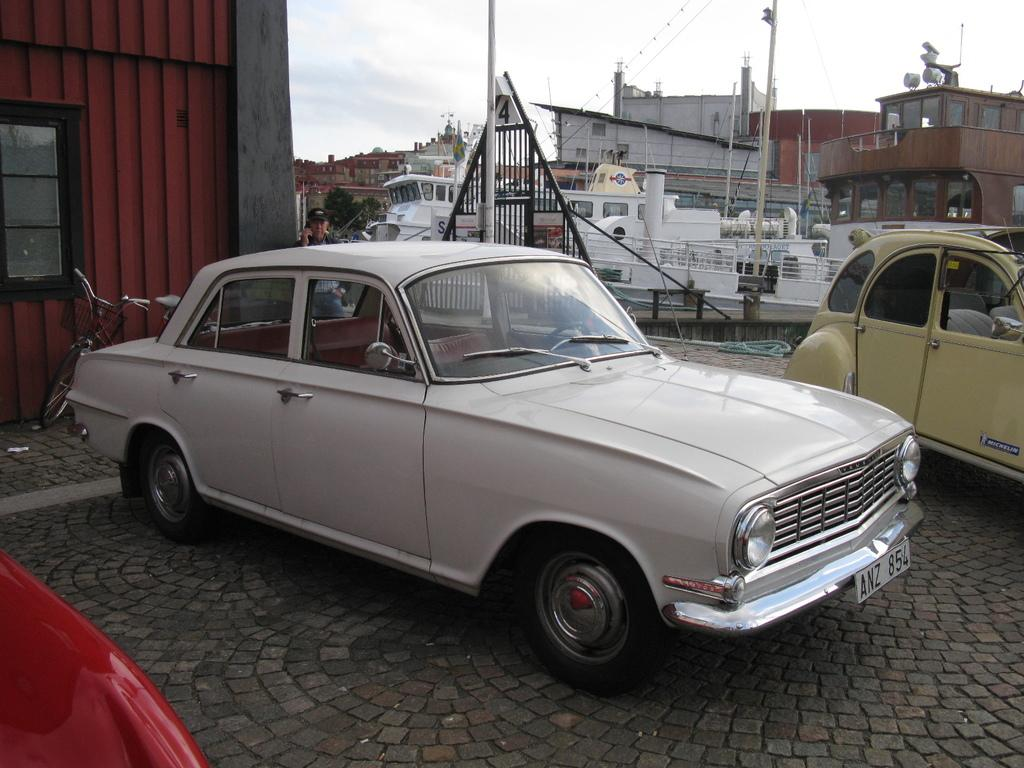What type of vehicles are on the land in the image? There are two cars on the land in the image. What can be seen in front of a building in the image? There is a cycle in front of a building in the image. What is visible in the background of the image? There appears to be a ship or a shipyard in the background of the image. What is visible at the top of the image? The sky is visible in the image. What type of knowledge is being imparted by the father in the image? There is no father or knowledge being imparted in the image; it features two cars, a cycle, a building, a ship or shipyard, and the sky. Is there a veil covering any part of the image? There is no veil present in the image. 